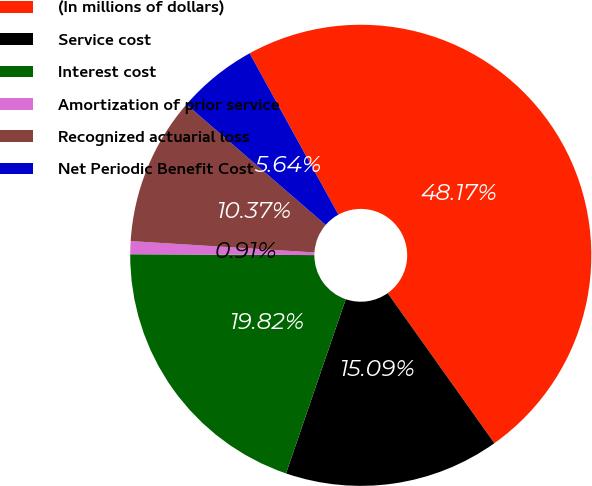Convert chart. <chart><loc_0><loc_0><loc_500><loc_500><pie_chart><fcel>(In millions of dollars)<fcel>Service cost<fcel>Interest cost<fcel>Amortization of prior service<fcel>Recognized actuarial loss<fcel>Net Periodic Benefit Cost<nl><fcel>48.17%<fcel>15.09%<fcel>19.82%<fcel>0.91%<fcel>10.37%<fcel>5.64%<nl></chart> 